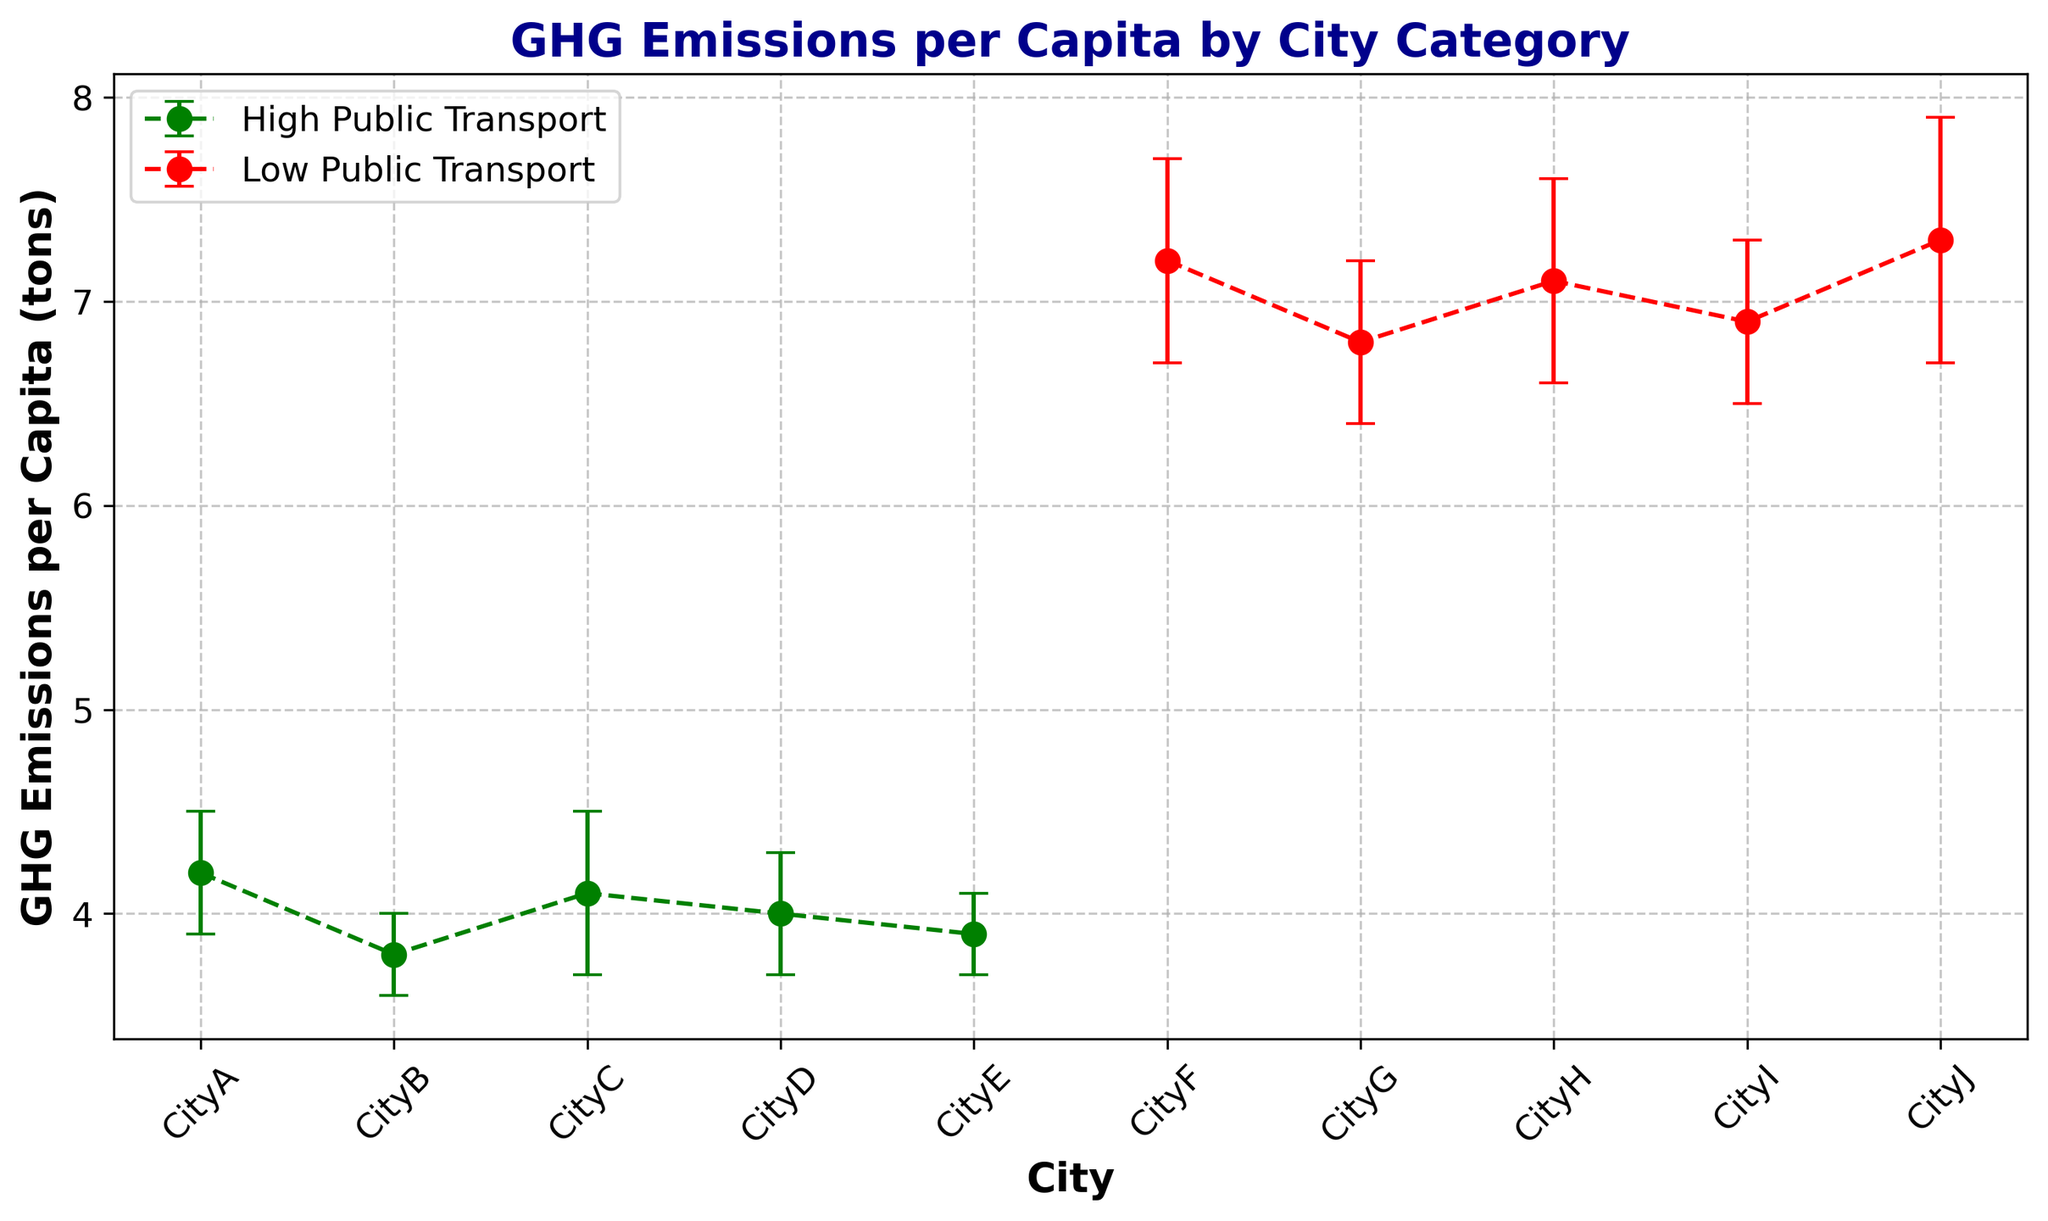What is the average GHG emissions per capita for cities with high public transport adoption rates? To compute the average, sum the GHG emissions per capita for CityA, CityB, CityC, CityD, and CityE, then divide by the number of cities. (4.2 + 3.8 + 4.1 + 4.0 + 3.9) / 5 = 20 / 5 = 4.0
Answer: 4.0 Which city has the highest GHG emissions per capita among those with low public transport adoption rates? Compare the GHG emissions per capita values for CityF, CityG, CityH, CityI, and CityJ. The highest value is 7.3 for CityJ.
Answer: CityJ What is the difference in average GHG emissions per capita between cities with high and low public transport adoption rates? Compute the average for both categories: High Public Transport is 4.0, and Low Public Transport is (7.2 + 6.8 + 7.1 + 6.9 + 7.3) / 5 = 35.3 / 5 = 7.06. The difference is 7.06 - 4.0 = 3.06
Answer: 3.06 Which group, High or Low Public Transport, has more consistent GHG emissions per capita based on the error bars? Compare the lengths of the error bars. High Public Transport cities have shorter error bars relative to their means compared to Low Public Transport cities, indicating more consistency.
Answer: High Public Transport Are there any cities in the High Public Transport group with GHG emissions per capita greater than the average emissions in the Low Public Transport group? The average emissions in the Low Public Transport group is 7.06. In the High group, all values (4.2, 3.8, 4.1, 4.0, 3.9) are less than 7.06.
Answer: No How does CityA's GHG emissions per capita compare to CityF's? CityA has 4.2, and CityF has 7.2. 4.2 is less than 7.2.
Answer: CityA < CityF What is the total standard deviation for GHG emissions per capita in cities with high public transport adoption rates? Sum the standard deviations of CityA, CityB, CityC, CityD, and CityE: 0.3 + 0.2 + 0.4 + 0.3 + 0.2 = 1.4
Answer: 1.4 Which city among the High Public Transport group has the smallest standard deviation? Compare the standard deviations: CityB and CityE both have the smallest value of 0.2.
Answer: CityB, CityE 